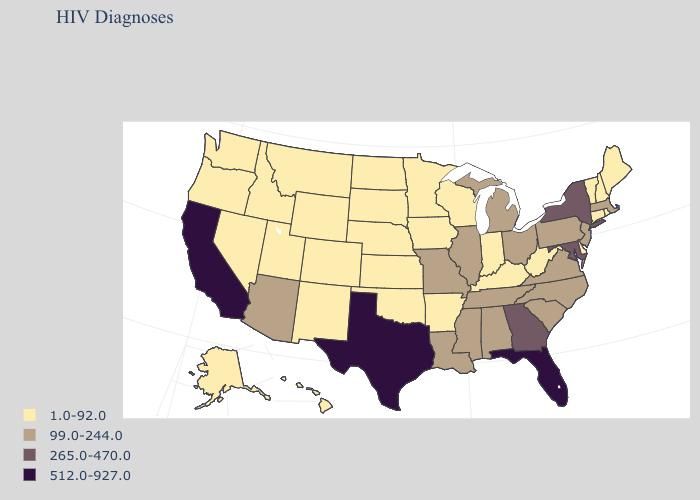Does New Mexico have a higher value than Kansas?
Answer briefly. No. Name the states that have a value in the range 1.0-92.0?
Short answer required. Alaska, Arkansas, Colorado, Connecticut, Delaware, Hawaii, Idaho, Indiana, Iowa, Kansas, Kentucky, Maine, Minnesota, Montana, Nebraska, Nevada, New Hampshire, New Mexico, North Dakota, Oklahoma, Oregon, Rhode Island, South Dakota, Utah, Vermont, Washington, West Virginia, Wisconsin, Wyoming. What is the value of Arkansas?
Answer briefly. 1.0-92.0. What is the value of New Jersey?
Give a very brief answer. 99.0-244.0. Among the states that border Indiana , which have the lowest value?
Be succinct. Kentucky. Does Louisiana have the lowest value in the USA?
Concise answer only. No. Among the states that border Pennsylvania , does West Virginia have the lowest value?
Answer briefly. Yes. Is the legend a continuous bar?
Concise answer only. No. What is the value of Connecticut?
Be succinct. 1.0-92.0. Does Colorado have the lowest value in the USA?
Short answer required. Yes. Name the states that have a value in the range 512.0-927.0?
Keep it brief. California, Florida, Texas. What is the lowest value in states that border New York?
Short answer required. 1.0-92.0. Which states have the highest value in the USA?
Be succinct. California, Florida, Texas. Name the states that have a value in the range 265.0-470.0?
Give a very brief answer. Georgia, Maryland, New York. Among the states that border South Dakota , which have the highest value?
Answer briefly. Iowa, Minnesota, Montana, Nebraska, North Dakota, Wyoming. 